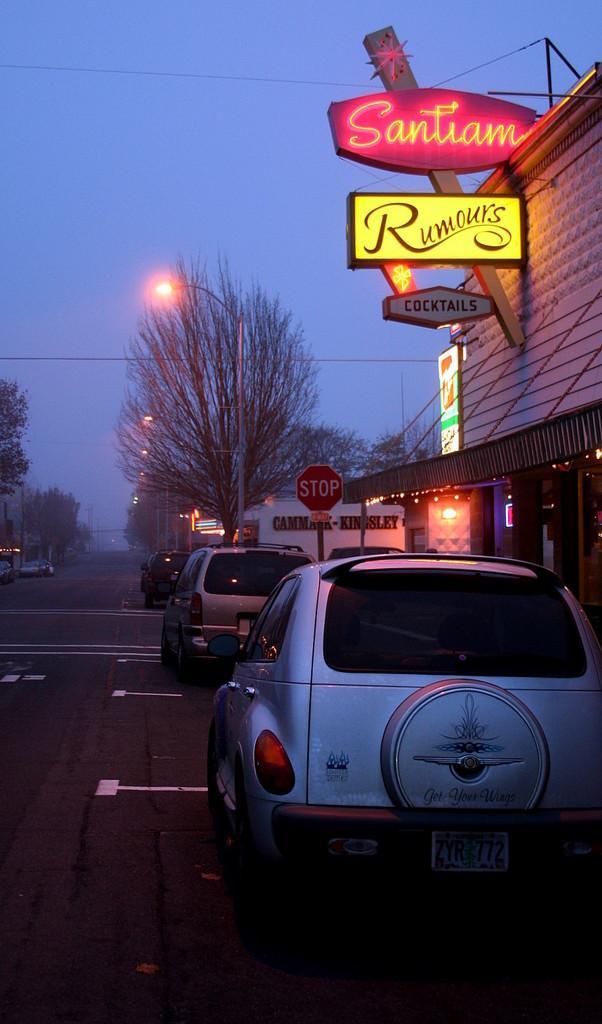Please provide a concise description of this image. This image consists of cars parked on the roads. On the right, we can see a building. It looks like a restaurant. In the background, there are trees along with the lights. At the top, there is sky. At the bottom, there is a road. 